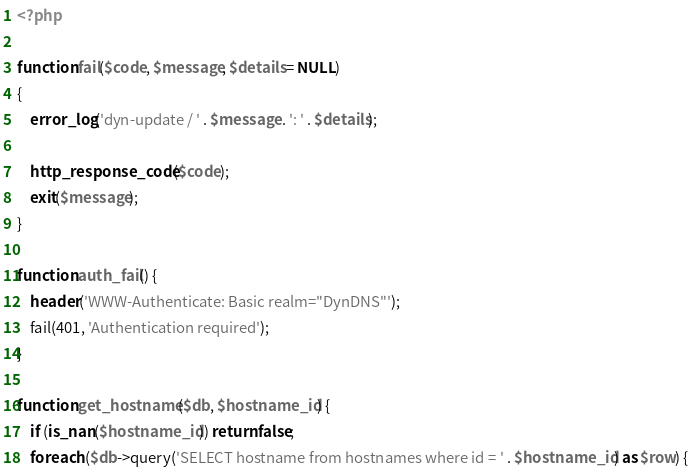<code> <loc_0><loc_0><loc_500><loc_500><_PHP_><?php

function fail($code, $message, $details = NULL)
{
    error_log('dyn-update / ' . $message . ': ' . $details);

    http_response_code($code);
    exit($message);
}

function auth_fail() {
    header('WWW-Authenticate: Basic realm="DynDNS"');
    fail(401, 'Authentication required');
}

function get_hostname($db, $hostname_id) {
    if (is_nan($hostname_id)) return false;
    foreach ($db->query('SELECT hostname from hostnames where id = ' . $hostname_id) as $row) {</code> 